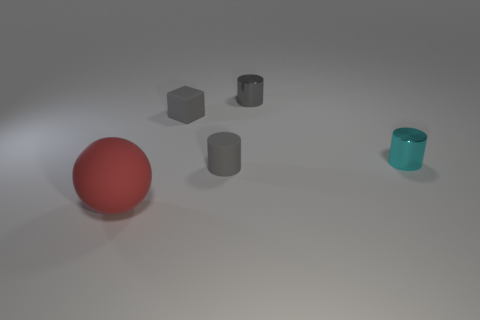Are there any other things that have the same size as the ball?
Your answer should be compact. No. What material is the cube that is the same color as the matte cylinder?
Make the answer very short. Rubber. There is a red thing that is made of the same material as the tiny gray cube; what shape is it?
Ensure brevity in your answer.  Sphere. Are there more tiny gray rubber objects to the right of the big red matte object than cylinders right of the tiny matte cylinder?
Make the answer very short. No. What number of objects are purple shiny objects or gray objects?
Offer a terse response. 3. What number of other things are there of the same color as the small cube?
Offer a terse response. 2. There is a metallic thing that is the same size as the cyan metallic cylinder; what shape is it?
Provide a short and direct response. Cylinder. The large rubber thing that is on the left side of the tiny gray metal thing is what color?
Ensure brevity in your answer.  Red. How many objects are either rubber objects on the right side of the big red sphere or things right of the matte sphere?
Provide a short and direct response. 4. Do the rubber block and the cyan cylinder have the same size?
Your response must be concise. Yes. 